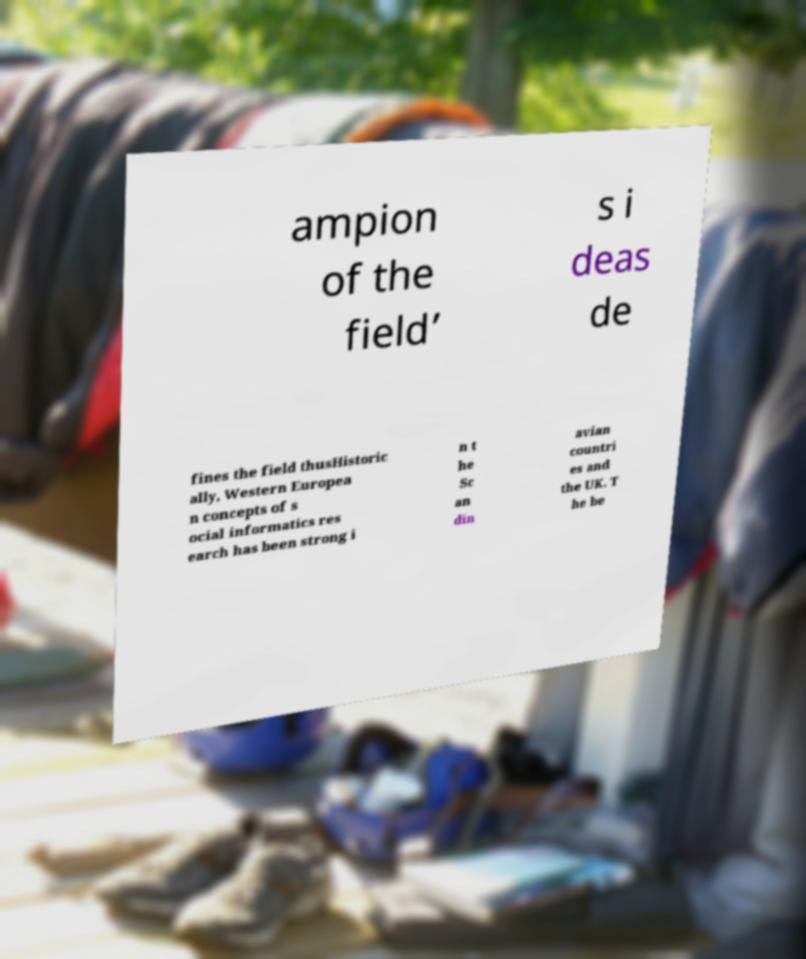What messages or text are displayed in this image? I need them in a readable, typed format. ampion of the field’ s i deas de fines the field thusHistoric ally, Western Europea n concepts of s ocial informatics res earch has been strong i n t he Sc an din avian countri es and the UK. T he be 